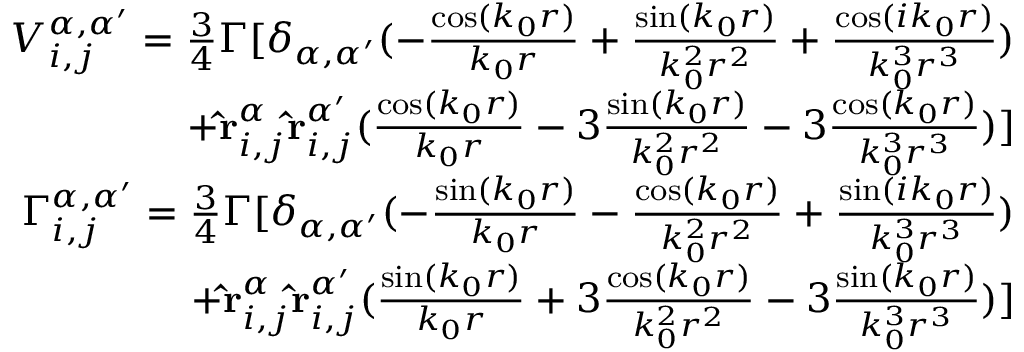<formula> <loc_0><loc_0><loc_500><loc_500>\begin{array} { r } { V _ { i , j } ^ { \alpha , \alpha ^ { \prime } } = \frac { 3 } { 4 } \Gamma [ \delta _ { \alpha , \alpha ^ { \prime } } ( - \frac { \cos ( k _ { 0 } r ) } { k _ { 0 } r } + \frac { \sin ( k _ { 0 } r ) } { k _ { 0 } ^ { 2 } r ^ { 2 } } + \frac { \cos ( i k _ { 0 } r ) } { k _ { 0 } ^ { 3 } r ^ { 3 } } ) } \\ { + \hat { r } _ { i , j } ^ { \alpha } \hat { r } _ { i , j } ^ { \alpha ^ { \prime } } ( \frac { \cos ( k _ { 0 } r ) } { k _ { 0 } r } - 3 \frac { \sin ( k _ { 0 } r ) } { k _ { 0 } ^ { 2 } r ^ { 2 } } - 3 \frac { \cos ( k _ { 0 } r ) } { k _ { 0 } ^ { 3 } r ^ { 3 } } ) ] } \\ { \Gamma _ { i , j } ^ { \alpha , \alpha ^ { \prime } } = \frac { 3 } { 4 } \Gamma [ \delta _ { \alpha , \alpha ^ { \prime } } ( - \frac { \sin ( k _ { 0 } r ) } { k _ { 0 } r } - \frac { \cos ( k _ { 0 } r ) } { k _ { 0 } ^ { 2 } r ^ { 2 } } + \frac { \sin ( i k _ { 0 } r ) } { k _ { 0 } ^ { 3 } r ^ { 3 } } ) } \\ { + \hat { r } _ { i , j } ^ { \alpha } \hat { r } _ { i , j } ^ { \alpha ^ { \prime } } ( \frac { \sin ( k _ { 0 } r ) } { k _ { 0 } r } + 3 \frac { \cos ( k _ { 0 } r ) } { k _ { 0 } ^ { 2 } r ^ { 2 } } - 3 \frac { \sin ( k _ { 0 } r ) } { k _ { 0 } ^ { 3 } r ^ { 3 } } ) ] } \end{array}</formula> 